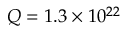Convert formula to latex. <formula><loc_0><loc_0><loc_500><loc_500>Q = 1 . 3 \times 1 0 ^ { 2 2 }</formula> 